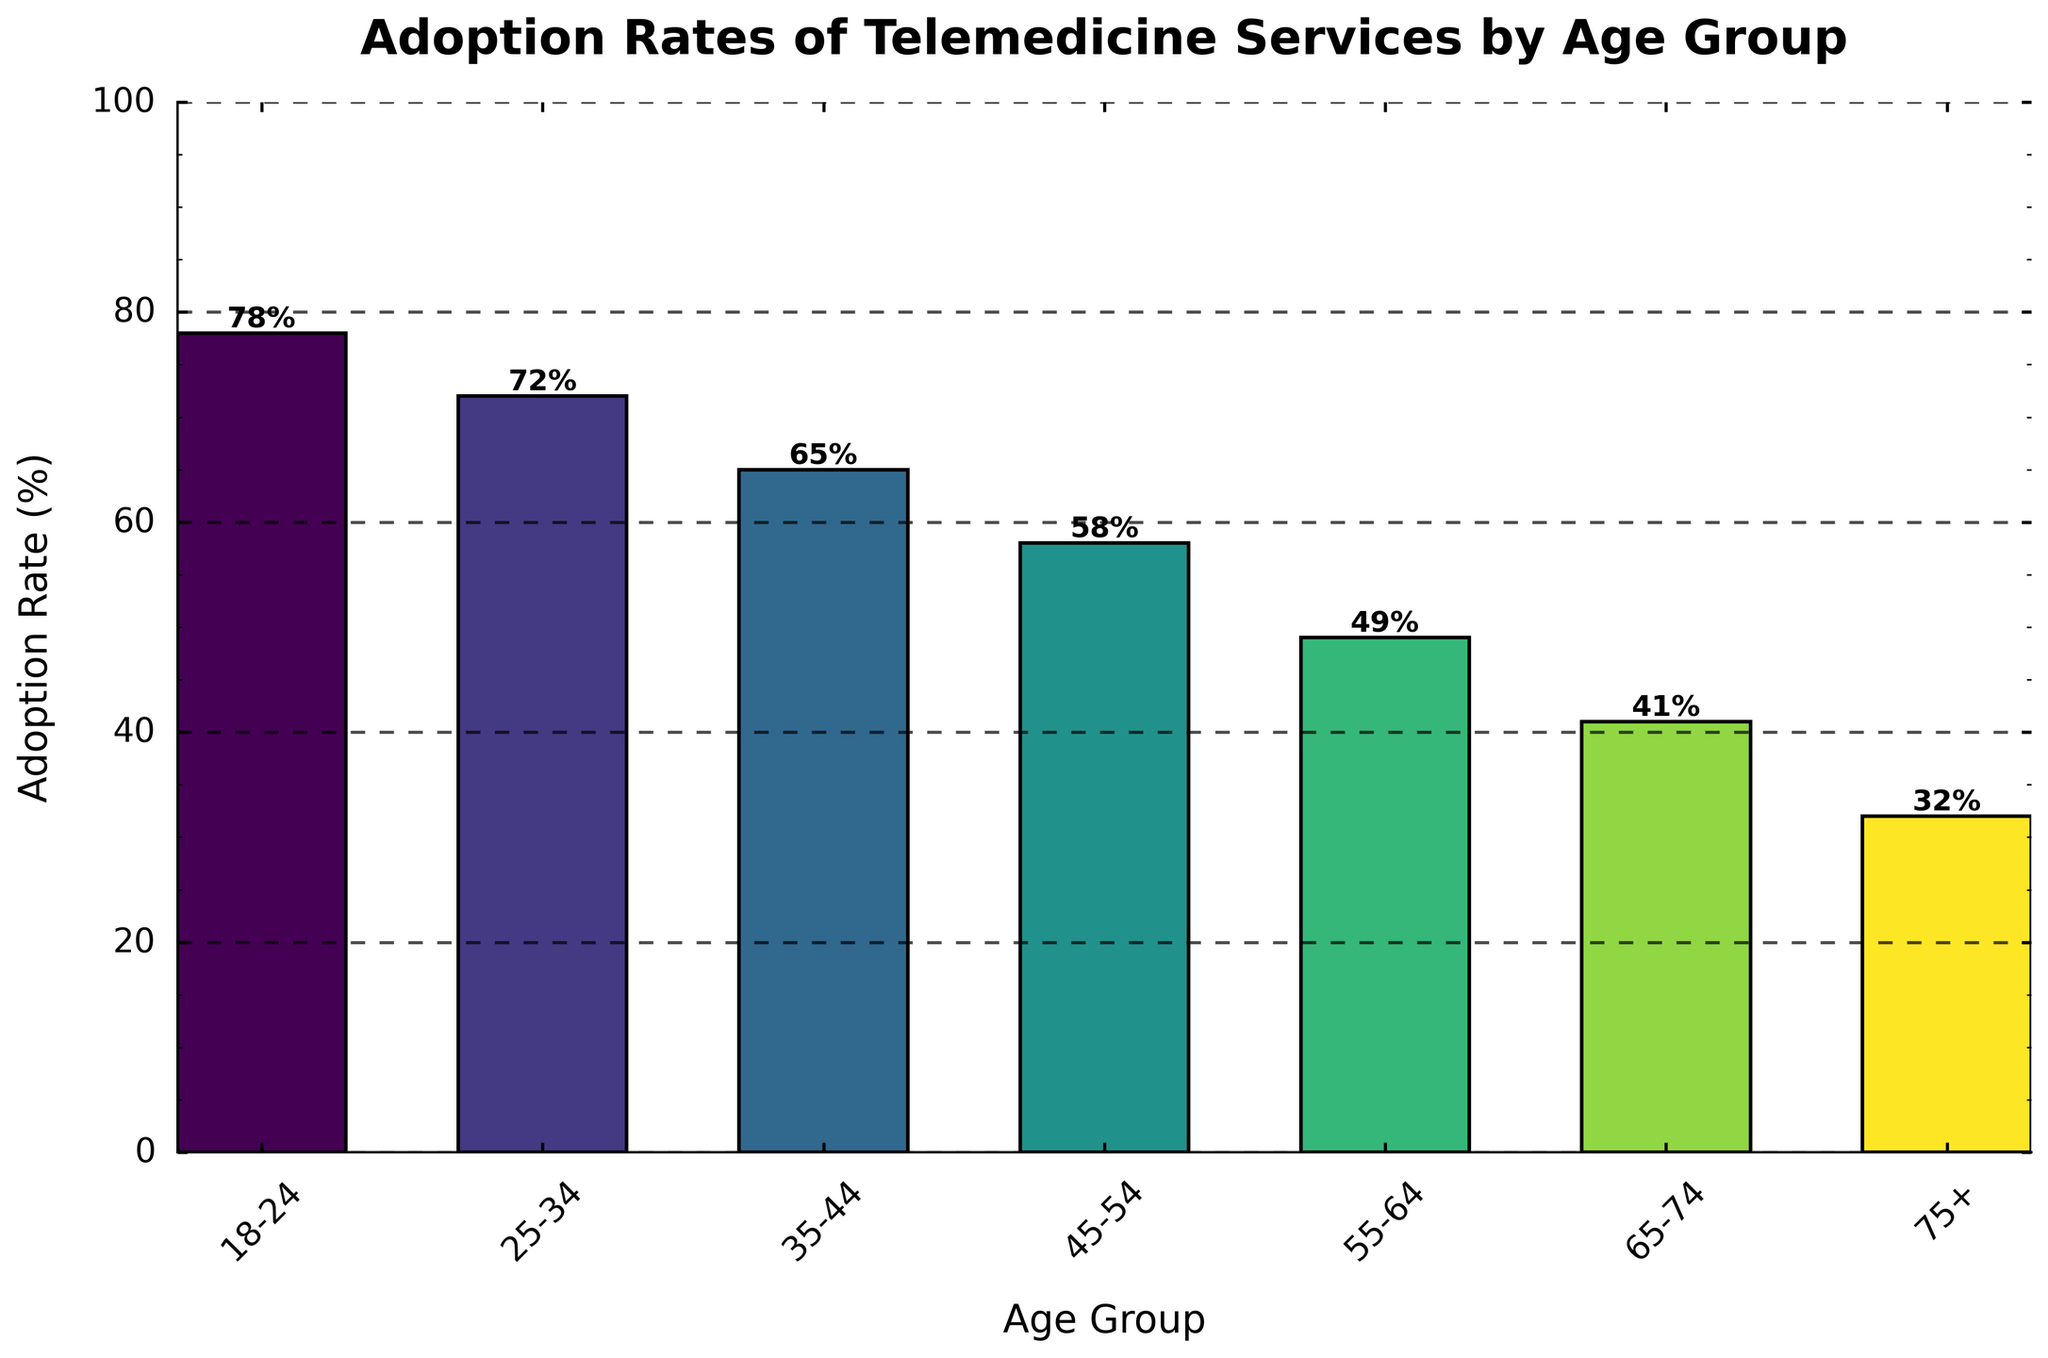Which age group has the highest adoption rate of telemedicine services? The figure shows that the adoption rate of telemedicine services is represented by the height of the bars. The tallest bar corresponds to the 18-24 age group with an adoption rate of 78%.
Answer: 18-24 Which age group has the lowest adoption rate of telemedicine services? The figure shows that the adoption rate of telemedicine services is represented by the height of the bars. The shortest bar corresponds to the 75+ age group with an adoption rate of 32%.
Answer: 75+ What is the difference in adoption rates between the 18-24 and 75+ age groups? To find the difference, subtract the adoption rate of the 75+ age group from that of the 18-24 age group. The rates are 78% and 32% respectively, so 78 - 32 = 46.
Answer: 46 By how much does the adoption rate decrease from the 25-34 age group to the 35-44 age group? The adoption rate for the 25-34 age group is 72% and for the 35-44 age group is 65%. Subtracting these gives 72 - 65 = 7.
Answer: 7 Which age group has adoption rates within 5% of the 55-64 age group? The adoption rate for the 55-64 age group is 49%. The group with an adoption rate within 5% would fall between 44% and 54%. The 65-74 age group has a rate of 41%, which is not within this range. Therefore, no age group matches this criterion.
Answer: None What is the median adoption rate for the age groups listed? To find the median, list the adoption rates in ascending order: 32%, 41%, 49%, 58%, 65%, 72%, 78%. The middle value in this ordered list (where there are 7 values) is the 4th value, which is 58%.
Answer: 58 How many age groups have an adoption rate higher than 60%? The figure shows that the age groups 18-24 (78%), 25-34 (72%), and 35-44 (65%) have adoption rates higher than 60%. Therefore, there are 3 age groups.
Answer: 3 Does the adoption rate generally increase or decrease with age? Observing the bar chart, the bars decrease in height as the age groups increase, indicating that the adoption rate decreases with age.
Answer: Decrease 